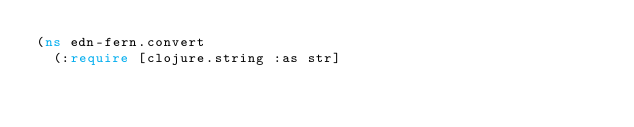<code> <loc_0><loc_0><loc_500><loc_500><_Clojure_>(ns edn-fern.convert
  (:require [clojure.string :as str]</code> 